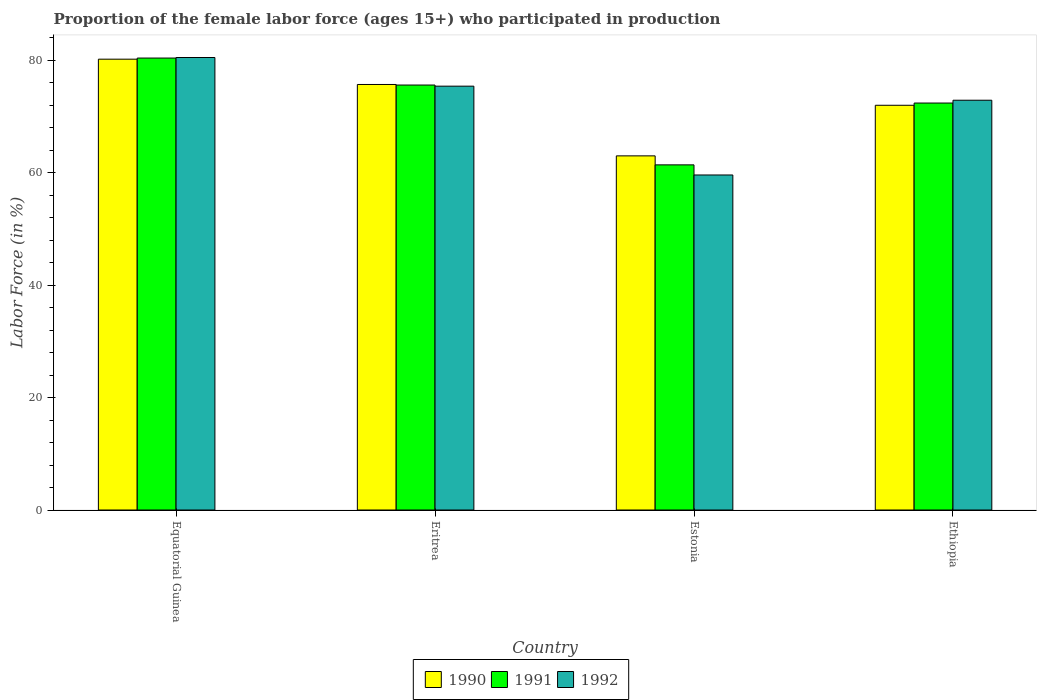How many different coloured bars are there?
Your answer should be compact. 3. How many groups of bars are there?
Make the answer very short. 4. Are the number of bars per tick equal to the number of legend labels?
Your answer should be very brief. Yes. Are the number of bars on each tick of the X-axis equal?
Offer a terse response. Yes. What is the label of the 1st group of bars from the left?
Make the answer very short. Equatorial Guinea. In how many cases, is the number of bars for a given country not equal to the number of legend labels?
Your response must be concise. 0. What is the proportion of the female labor force who participated in production in 1991 in Estonia?
Your answer should be very brief. 61.4. Across all countries, what is the maximum proportion of the female labor force who participated in production in 1990?
Give a very brief answer. 80.2. Across all countries, what is the minimum proportion of the female labor force who participated in production in 1992?
Your response must be concise. 59.6. In which country was the proportion of the female labor force who participated in production in 1991 maximum?
Provide a succinct answer. Equatorial Guinea. In which country was the proportion of the female labor force who participated in production in 1992 minimum?
Offer a very short reply. Estonia. What is the total proportion of the female labor force who participated in production in 1990 in the graph?
Offer a terse response. 290.9. What is the difference between the proportion of the female labor force who participated in production in 1991 in Equatorial Guinea and that in Ethiopia?
Offer a terse response. 8. What is the difference between the proportion of the female labor force who participated in production in 1991 in Equatorial Guinea and the proportion of the female labor force who participated in production in 1992 in Estonia?
Offer a very short reply. 20.8. What is the average proportion of the female labor force who participated in production in 1990 per country?
Make the answer very short. 72.72. What is the difference between the proportion of the female labor force who participated in production of/in 1990 and proportion of the female labor force who participated in production of/in 1991 in Equatorial Guinea?
Provide a succinct answer. -0.2. What is the ratio of the proportion of the female labor force who participated in production in 1991 in Estonia to that in Ethiopia?
Your answer should be very brief. 0.85. What is the difference between the highest and the second highest proportion of the female labor force who participated in production in 1992?
Give a very brief answer. 7.6. What is the difference between the highest and the lowest proportion of the female labor force who participated in production in 1992?
Offer a terse response. 20.9. What does the 3rd bar from the right in Ethiopia represents?
Your answer should be very brief. 1990. Are all the bars in the graph horizontal?
Give a very brief answer. No. How are the legend labels stacked?
Keep it short and to the point. Horizontal. What is the title of the graph?
Your answer should be very brief. Proportion of the female labor force (ages 15+) who participated in production. Does "2009" appear as one of the legend labels in the graph?
Offer a very short reply. No. What is the Labor Force (in %) in 1990 in Equatorial Guinea?
Offer a very short reply. 80.2. What is the Labor Force (in %) in 1991 in Equatorial Guinea?
Provide a short and direct response. 80.4. What is the Labor Force (in %) in 1992 in Equatorial Guinea?
Your response must be concise. 80.5. What is the Labor Force (in %) of 1990 in Eritrea?
Your answer should be very brief. 75.7. What is the Labor Force (in %) of 1991 in Eritrea?
Offer a very short reply. 75.6. What is the Labor Force (in %) of 1992 in Eritrea?
Offer a terse response. 75.4. What is the Labor Force (in %) in 1990 in Estonia?
Your answer should be very brief. 63. What is the Labor Force (in %) of 1991 in Estonia?
Provide a succinct answer. 61.4. What is the Labor Force (in %) in 1992 in Estonia?
Your answer should be compact. 59.6. What is the Labor Force (in %) in 1991 in Ethiopia?
Make the answer very short. 72.4. What is the Labor Force (in %) in 1992 in Ethiopia?
Offer a very short reply. 72.9. Across all countries, what is the maximum Labor Force (in %) in 1990?
Your answer should be compact. 80.2. Across all countries, what is the maximum Labor Force (in %) of 1991?
Ensure brevity in your answer.  80.4. Across all countries, what is the maximum Labor Force (in %) of 1992?
Provide a short and direct response. 80.5. Across all countries, what is the minimum Labor Force (in %) of 1991?
Ensure brevity in your answer.  61.4. Across all countries, what is the minimum Labor Force (in %) of 1992?
Give a very brief answer. 59.6. What is the total Labor Force (in %) of 1990 in the graph?
Give a very brief answer. 290.9. What is the total Labor Force (in %) of 1991 in the graph?
Your answer should be very brief. 289.8. What is the total Labor Force (in %) of 1992 in the graph?
Your response must be concise. 288.4. What is the difference between the Labor Force (in %) in 1991 in Equatorial Guinea and that in Eritrea?
Your answer should be very brief. 4.8. What is the difference between the Labor Force (in %) of 1990 in Equatorial Guinea and that in Estonia?
Your answer should be very brief. 17.2. What is the difference between the Labor Force (in %) in 1992 in Equatorial Guinea and that in Estonia?
Provide a short and direct response. 20.9. What is the difference between the Labor Force (in %) in 1991 in Eritrea and that in Estonia?
Give a very brief answer. 14.2. What is the difference between the Labor Force (in %) in 1990 in Eritrea and that in Ethiopia?
Your answer should be compact. 3.7. What is the difference between the Labor Force (in %) in 1991 in Eritrea and that in Ethiopia?
Your answer should be very brief. 3.2. What is the difference between the Labor Force (in %) of 1992 in Eritrea and that in Ethiopia?
Give a very brief answer. 2.5. What is the difference between the Labor Force (in %) in 1991 in Estonia and that in Ethiopia?
Ensure brevity in your answer.  -11. What is the difference between the Labor Force (in %) of 1990 in Equatorial Guinea and the Labor Force (in %) of 1992 in Eritrea?
Offer a very short reply. 4.8. What is the difference between the Labor Force (in %) of 1990 in Equatorial Guinea and the Labor Force (in %) of 1992 in Estonia?
Your answer should be compact. 20.6. What is the difference between the Labor Force (in %) in 1991 in Equatorial Guinea and the Labor Force (in %) in 1992 in Estonia?
Provide a short and direct response. 20.8. What is the difference between the Labor Force (in %) of 1990 in Equatorial Guinea and the Labor Force (in %) of 1991 in Ethiopia?
Your answer should be compact. 7.8. What is the difference between the Labor Force (in %) in 1991 in Equatorial Guinea and the Labor Force (in %) in 1992 in Ethiopia?
Your answer should be compact. 7.5. What is the difference between the Labor Force (in %) of 1990 in Eritrea and the Labor Force (in %) of 1991 in Ethiopia?
Your answer should be very brief. 3.3. What is the difference between the Labor Force (in %) of 1990 in Eritrea and the Labor Force (in %) of 1992 in Ethiopia?
Give a very brief answer. 2.8. What is the difference between the Labor Force (in %) in 1991 in Eritrea and the Labor Force (in %) in 1992 in Ethiopia?
Your response must be concise. 2.7. What is the difference between the Labor Force (in %) in 1990 in Estonia and the Labor Force (in %) in 1991 in Ethiopia?
Offer a very short reply. -9.4. What is the difference between the Labor Force (in %) in 1990 in Estonia and the Labor Force (in %) in 1992 in Ethiopia?
Provide a short and direct response. -9.9. What is the difference between the Labor Force (in %) of 1991 in Estonia and the Labor Force (in %) of 1992 in Ethiopia?
Offer a terse response. -11.5. What is the average Labor Force (in %) in 1990 per country?
Offer a terse response. 72.72. What is the average Labor Force (in %) of 1991 per country?
Offer a terse response. 72.45. What is the average Labor Force (in %) of 1992 per country?
Ensure brevity in your answer.  72.1. What is the difference between the Labor Force (in %) of 1990 and Labor Force (in %) of 1991 in Equatorial Guinea?
Make the answer very short. -0.2. What is the difference between the Labor Force (in %) of 1990 and Labor Force (in %) of 1991 in Eritrea?
Give a very brief answer. 0.1. What is the difference between the Labor Force (in %) in 1991 and Labor Force (in %) in 1992 in Eritrea?
Your response must be concise. 0.2. What is the difference between the Labor Force (in %) in 1990 and Labor Force (in %) in 1991 in Estonia?
Offer a terse response. 1.6. What is the difference between the Labor Force (in %) in 1990 and Labor Force (in %) in 1992 in Ethiopia?
Make the answer very short. -0.9. What is the difference between the Labor Force (in %) of 1991 and Labor Force (in %) of 1992 in Ethiopia?
Your answer should be very brief. -0.5. What is the ratio of the Labor Force (in %) of 1990 in Equatorial Guinea to that in Eritrea?
Offer a terse response. 1.06. What is the ratio of the Labor Force (in %) of 1991 in Equatorial Guinea to that in Eritrea?
Offer a terse response. 1.06. What is the ratio of the Labor Force (in %) of 1992 in Equatorial Guinea to that in Eritrea?
Your answer should be very brief. 1.07. What is the ratio of the Labor Force (in %) of 1990 in Equatorial Guinea to that in Estonia?
Make the answer very short. 1.27. What is the ratio of the Labor Force (in %) of 1991 in Equatorial Guinea to that in Estonia?
Make the answer very short. 1.31. What is the ratio of the Labor Force (in %) of 1992 in Equatorial Guinea to that in Estonia?
Your answer should be very brief. 1.35. What is the ratio of the Labor Force (in %) in 1990 in Equatorial Guinea to that in Ethiopia?
Provide a succinct answer. 1.11. What is the ratio of the Labor Force (in %) in 1991 in Equatorial Guinea to that in Ethiopia?
Your answer should be compact. 1.11. What is the ratio of the Labor Force (in %) of 1992 in Equatorial Guinea to that in Ethiopia?
Your response must be concise. 1.1. What is the ratio of the Labor Force (in %) of 1990 in Eritrea to that in Estonia?
Your answer should be very brief. 1.2. What is the ratio of the Labor Force (in %) in 1991 in Eritrea to that in Estonia?
Offer a terse response. 1.23. What is the ratio of the Labor Force (in %) of 1992 in Eritrea to that in Estonia?
Your answer should be very brief. 1.27. What is the ratio of the Labor Force (in %) in 1990 in Eritrea to that in Ethiopia?
Keep it short and to the point. 1.05. What is the ratio of the Labor Force (in %) in 1991 in Eritrea to that in Ethiopia?
Make the answer very short. 1.04. What is the ratio of the Labor Force (in %) in 1992 in Eritrea to that in Ethiopia?
Make the answer very short. 1.03. What is the ratio of the Labor Force (in %) in 1990 in Estonia to that in Ethiopia?
Offer a very short reply. 0.88. What is the ratio of the Labor Force (in %) of 1991 in Estonia to that in Ethiopia?
Your answer should be compact. 0.85. What is the ratio of the Labor Force (in %) in 1992 in Estonia to that in Ethiopia?
Offer a terse response. 0.82. What is the difference between the highest and the lowest Labor Force (in %) in 1992?
Give a very brief answer. 20.9. 